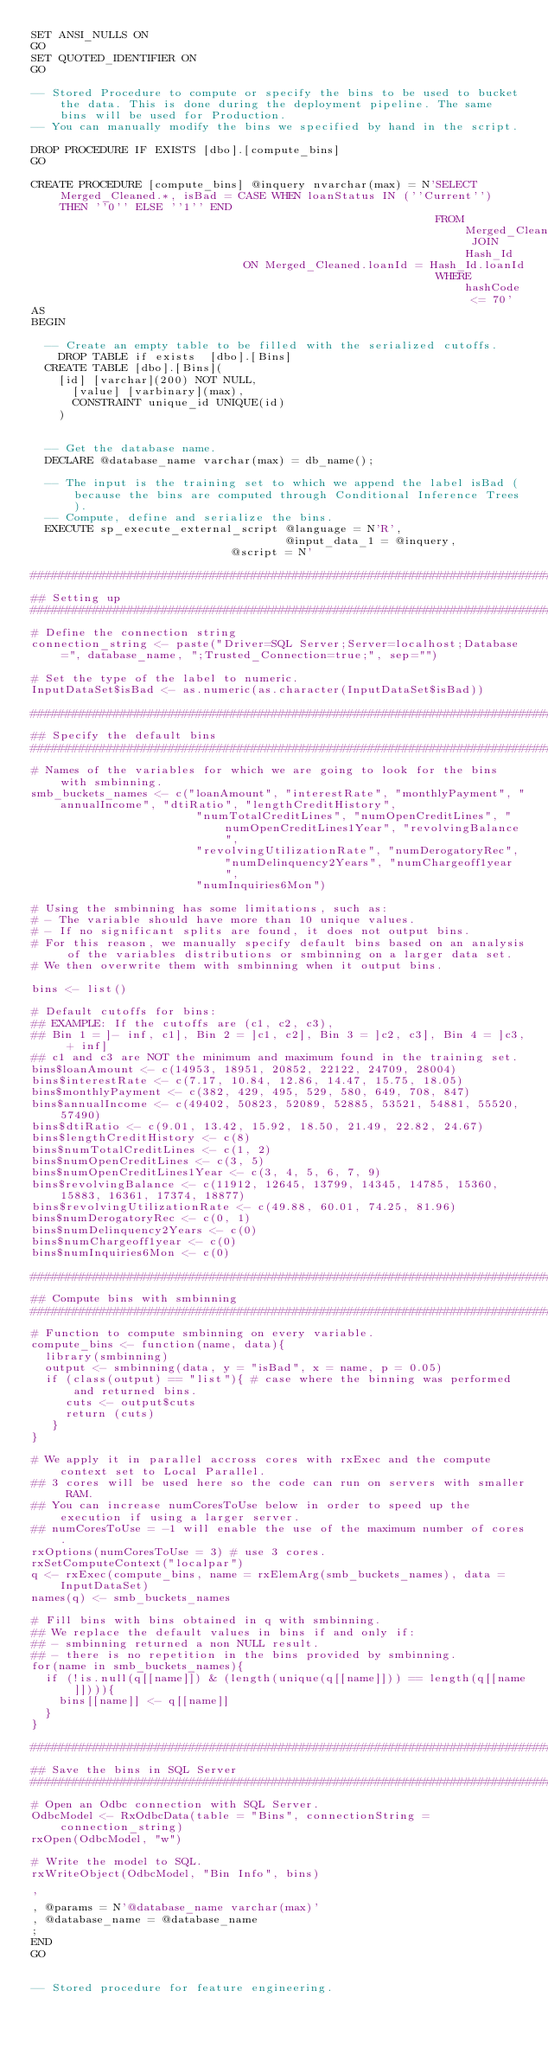Convert code to text. <code><loc_0><loc_0><loc_500><loc_500><_SQL_>SET ANSI_NULLS ON
GO
SET QUOTED_IDENTIFIER ON
GO

-- Stored Procedure to compute or specify the bins to be used to bucket the data. This is done during the deployment pipeline. The same bins will be used for Production. 
-- You can manually modify the bins we specified by hand in the script. 

DROP PROCEDURE IF EXISTS [dbo].[compute_bins]  
GO

CREATE PROCEDURE [compute_bins] @inquery nvarchar(max) = N'SELECT Merged_Cleaned.*, isBad = CASE WHEN loanStatus IN (''Current'') THEN ''0'' ELSE ''1'' END
                                                           FROM  Merged_Cleaned JOIN Hash_Id 
														   ON Merged_Cleaned.loanId = Hash_Id.loanId
                                                           WHERE hashCode <= 70'
AS 
BEGIN

	-- Create an empty table to be filled with the serialized cutoffs. 
    DROP TABLE if exists  [dbo].[Bins]
	CREATE TABLE [dbo].[Bins](
		[id] [varchar](200) NOT NULL, 
	    [value] [varbinary](max), 
			CONSTRAINT unique_id UNIQUE(id)
		) 
		

	-- Get the database name.
	DECLARE @database_name varchar(max) = db_name();

	-- The input is the training set to which we append the label isBad (because the bins are computed through Conditional Inference Trees).
	-- Compute, define and serialize the bins. 
	EXECUTE sp_execute_external_script @language = N'R',
	                                   @input_data_1 = @inquery,
     					               @script = N' 

########################################################################################################################################## 
## Setting up
########################################################################################################################################## 
# Define the connection string
connection_string <- paste("Driver=SQL Server;Server=localhost;Database=", database_name, ";Trusted_Connection=true;", sep="")

# Set the type of the label to numeric. 
InputDataSet$isBad <- as.numeric(as.character(InputDataSet$isBad))

########################################################################################################################################## 
## Specify the default bins
########################################################################################################################################## 
# Names of the variables for which we are going to look for the bins with smbinning. 
smb_buckets_names <- c("loanAmount", "interestRate", "monthlyPayment", "annualIncome", "dtiRatio", "lengthCreditHistory",
                        "numTotalCreditLines", "numOpenCreditLines", "numOpenCreditLines1Year", "revolvingBalance",
                        "revolvingUtilizationRate", "numDerogatoryRec", "numDelinquency2Years", "numChargeoff1year", 
                        "numInquiries6Mon")
  
# Using the smbinning has some limitations, such as: 
# - The variable should have more than 10 unique values. 
# - If no significant splits are found, it does not output bins. 
# For this reason, we manually specify default bins based on an analysis of the variables distributions or smbinning on a larger data set. 
# We then overwrite them with smbinning when it output bins. 
  
bins <- list()
  
# Default cutoffs for bins:
## EXAMPLE: If the cutoffs are (c1, c2, c3),
## Bin 1 = ]- inf, c1], Bin 2 = ]c1, c2], Bin 3 = ]c2, c3], Bin 4 = ]c3, + inf] 
## c1 and c3 are NOT the minimum and maximum found in the training set. 
bins$loanAmount <- c(14953, 18951, 20852, 22122, 24709, 28004)
bins$interestRate <- c(7.17, 10.84, 12.86, 14.47, 15.75, 18.05)
bins$monthlyPayment <- c(382, 429, 495, 529, 580, 649, 708, 847)
bins$annualIncome <- c(49402, 50823, 52089, 52885, 53521, 54881, 55520, 57490)
bins$dtiRatio <- c(9.01, 13.42, 15.92, 18.50, 21.49, 22.82, 24.67)
bins$lengthCreditHistory <- c(8)
bins$numTotalCreditLines <- c(1, 2)
bins$numOpenCreditLines <- c(3, 5)
bins$numOpenCreditLines1Year <- c(3, 4, 5, 6, 7, 9)
bins$revolvingBalance <- c(11912, 12645, 13799, 14345, 14785, 15360, 15883, 16361, 17374, 18877)
bins$revolvingUtilizationRate <- c(49.88, 60.01, 74.25, 81.96)
bins$numDerogatoryRec <- c(0, 1)
bins$numDelinquency2Years <- c(0)
bins$numChargeoff1year <- c(0)
bins$numInquiries6Mon <- c(0)
  
########################################################################################################################################## 
## Compute bins with smbinning
########################################################################################################################################## 
# Function to compute smbinning on every variable. 
compute_bins <- function(name, data){
  library(smbinning)
  output <- smbinning(data, y = "isBad", x = name, p = 0.05)
  if (class(output) == "list"){ # case where the binning was performed and returned bins.
     cuts <- output$cuts  
     return (cuts)
   }
}
  
# We apply it in parallel accross cores with rxExec and the compute context set to Local Parallel.
## 3 cores will be used here so the code can run on servers with smaller RAM. 
## You can increase numCoresToUse below in order to speed up the execution if using a larger server.
## numCoresToUse = -1 will enable the use of the maximum number of cores.
rxOptions(numCoresToUse = 3) # use 3 cores.
rxSetComputeContext("localpar")
q <- rxExec(compute_bins, name = rxElemArg(smb_buckets_names), data = InputDataSet)
names(q) <- smb_buckets_names
  
# Fill bins with bins obtained in q with smbinning. 
## We replace the default values in bins if and only if: 
## - smbinning returned a non NULL result. 
## - there is no repetition in the bins provided by smbinning. 
for(name in smb_buckets_names){
  if (!is.null(q[[name]]) & (length(unique(q[[name]])) == length(q[[name]]))){ 
    bins[[name]] <- q[[name]]
  }
}

########################################################################################################################################## 
## Save the bins in SQL Server 
########################################################################################################################################## 
# Open an Odbc connection with SQL Server. 
OdbcModel <- RxOdbcData(table = "Bins", connectionString = connection_string) 
rxOpen(OdbcModel, "w") 

# Write the model to SQL.  
rxWriteObject(OdbcModel, "Bin Info", bins) 
 
'
, @params = N'@database_name varchar(max)'
, @database_name = @database_name 
;
END
GO


-- Stored procedure for feature engineering.</code> 